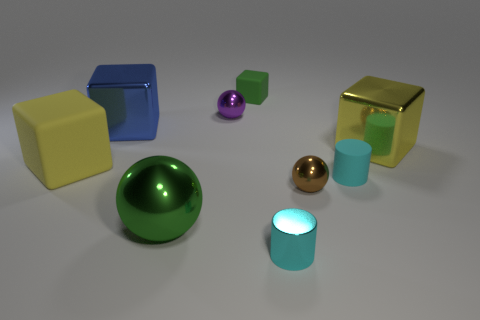Are there fewer large yellow objects than shiny objects?
Your answer should be compact. Yes. There is a cube that is both in front of the large blue block and right of the purple thing; what is its color?
Provide a short and direct response. Yellow. There is a brown object that is the same shape as the green metallic object; what material is it?
Give a very brief answer. Metal. Are there more yellow cubes than objects?
Your answer should be very brief. No. There is a rubber object that is both right of the big yellow rubber object and to the left of the brown metallic sphere; what is its size?
Your answer should be compact. Small. There is a brown object; what shape is it?
Your response must be concise. Sphere. What number of cyan matte things have the same shape as the green metal thing?
Your response must be concise. 0. Is the number of green things that are right of the green rubber block less than the number of metallic blocks on the right side of the large green metallic sphere?
Provide a short and direct response. Yes. What number of small things are behind the large yellow cube on the right side of the large yellow matte cube?
Ensure brevity in your answer.  2. Is there a green ball?
Your answer should be very brief. Yes. 